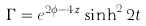<formula> <loc_0><loc_0><loc_500><loc_500>\Gamma = e ^ { 2 \phi - 4 z } \sinh ^ { 2 } 2 t</formula> 